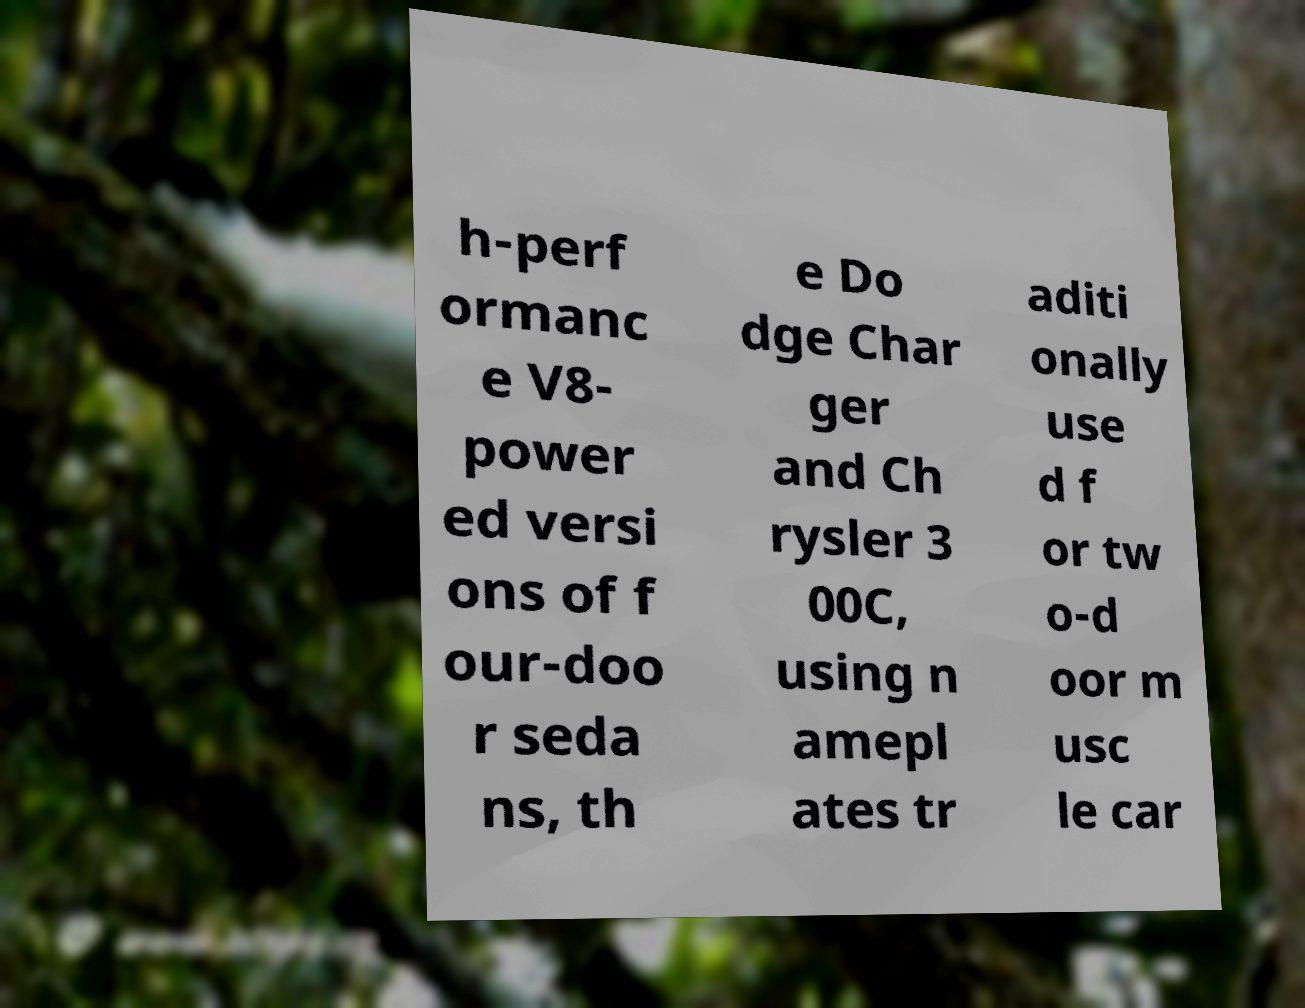Could you extract and type out the text from this image? h-perf ormanc e V8- power ed versi ons of f our-doo r seda ns, th e Do dge Char ger and Ch rysler 3 00C, using n amepl ates tr aditi onally use d f or tw o-d oor m usc le car 